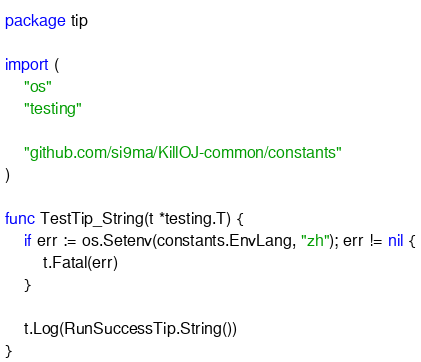<code> <loc_0><loc_0><loc_500><loc_500><_Go_>package tip

import (
	"os"
	"testing"

	"github.com/si9ma/KillOJ-common/constants"
)

func TestTip_String(t *testing.T) {
	if err := os.Setenv(constants.EnvLang, "zh"); err != nil {
		t.Fatal(err)
	}

	t.Log(RunSuccessTip.String())
}
</code> 